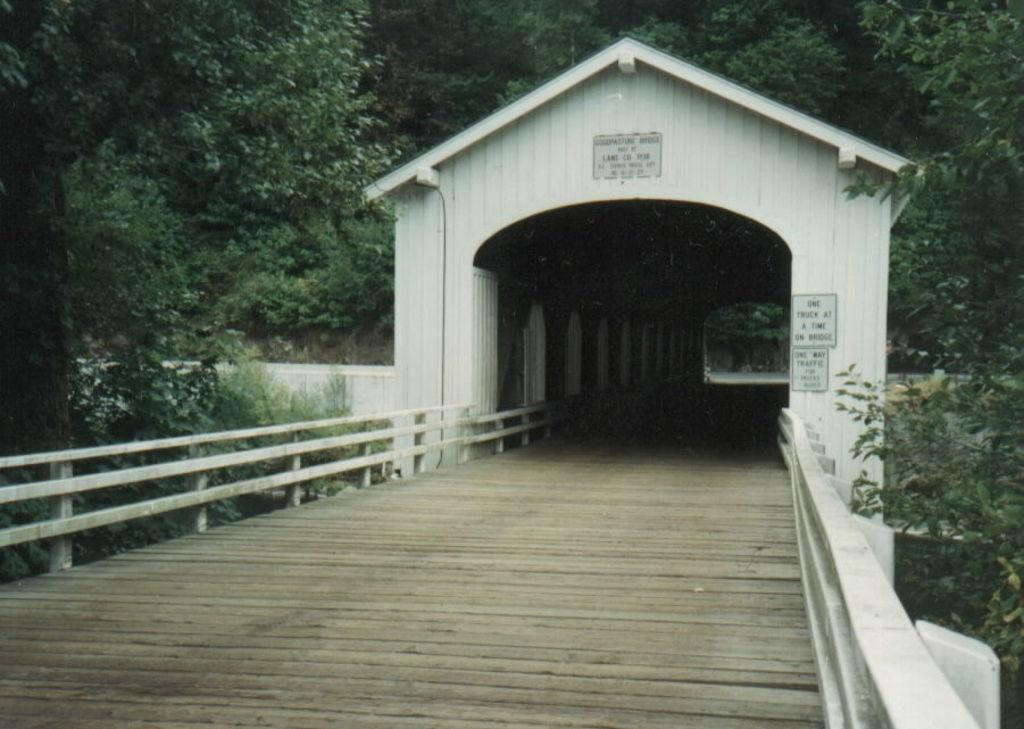Can you describe this image briefly? In this image I can see a path and a tunnel in the center. I can also see few boards and on these words I can see something is written. Both side of the tunnel I can see number of trees. 